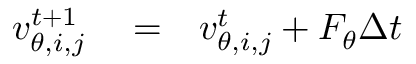Convert formula to latex. <formula><loc_0><loc_0><loc_500><loc_500>\begin{array} { r l r } { v _ { \theta , i , j } ^ { t + 1 } } & = } & { v _ { \theta , i , j } ^ { t } + F _ { \theta } \Delta t } \end{array}</formula> 